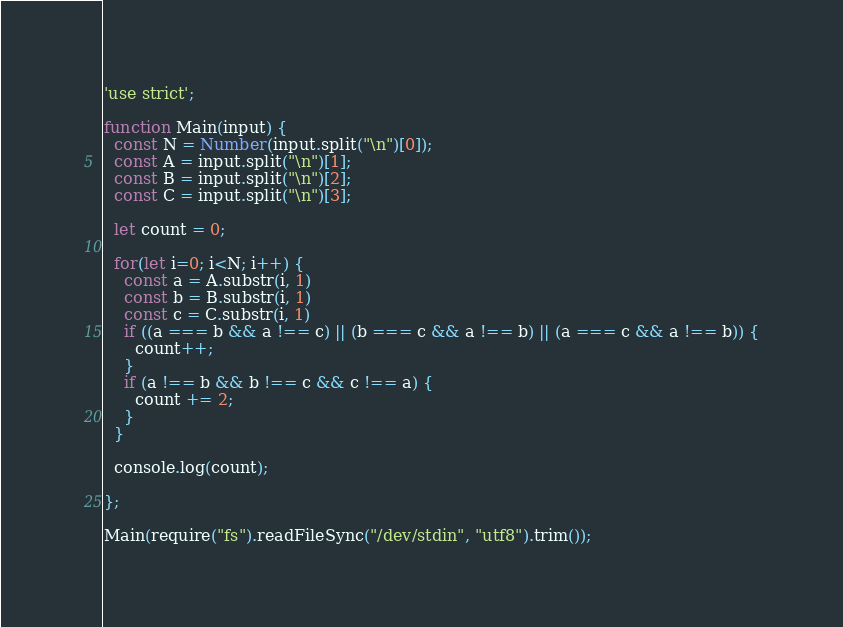<code> <loc_0><loc_0><loc_500><loc_500><_JavaScript_>'use strict';

function Main(input) {
  const N = Number(input.split("\n")[0]);
  const A = input.split("\n")[1];
  const B = input.split("\n")[2];
  const C = input.split("\n")[3];

  let count = 0;

  for(let i=0; i<N; i++) {
    const a = A.substr(i, 1)
    const b = B.substr(i, 1)
    const c = C.substr(i, 1)
    if ((a === b && a !== c) || (b === c && a !== b) || (a === c && a !== b)) {
      count++;
    }
    if (a !== b && b !== c && c !== a) {
      count += 2;
    }
  }

  console.log(count);

};

Main(require("fs").readFileSync("/dev/stdin", "utf8").trim());
</code> 